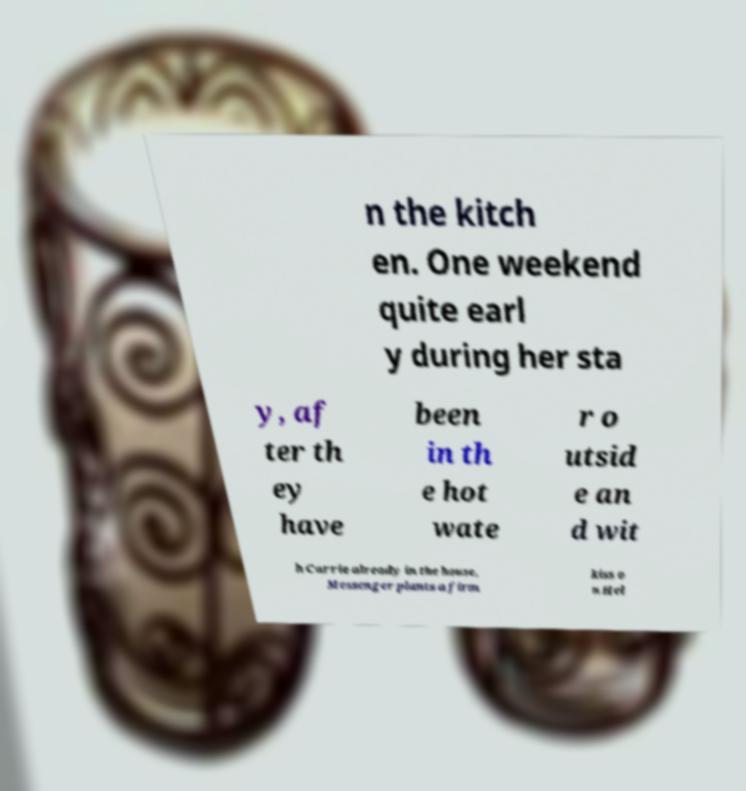For documentation purposes, I need the text within this image transcribed. Could you provide that? n the kitch en. One weekend quite earl y during her sta y, af ter th ey have been in th e hot wate r o utsid e an d wit h Carrie already in the house, Messenger plants a firm kiss o n Hel 